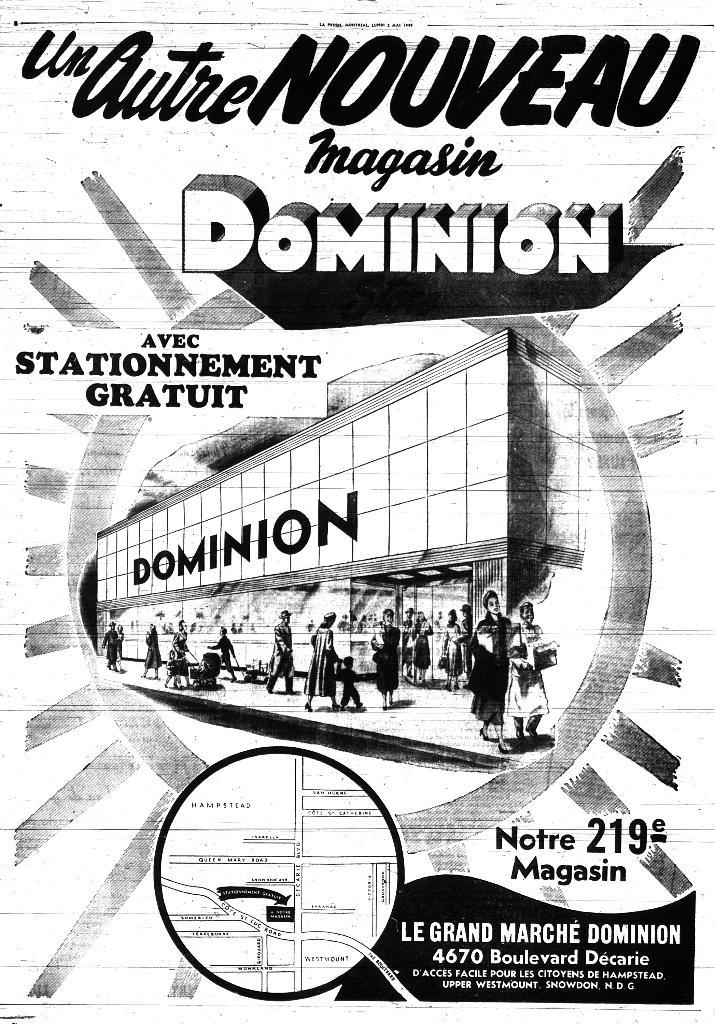<image>
Summarize the visual content of the image. A poster for a foreign language show called Un Autre NOUVEAU. 